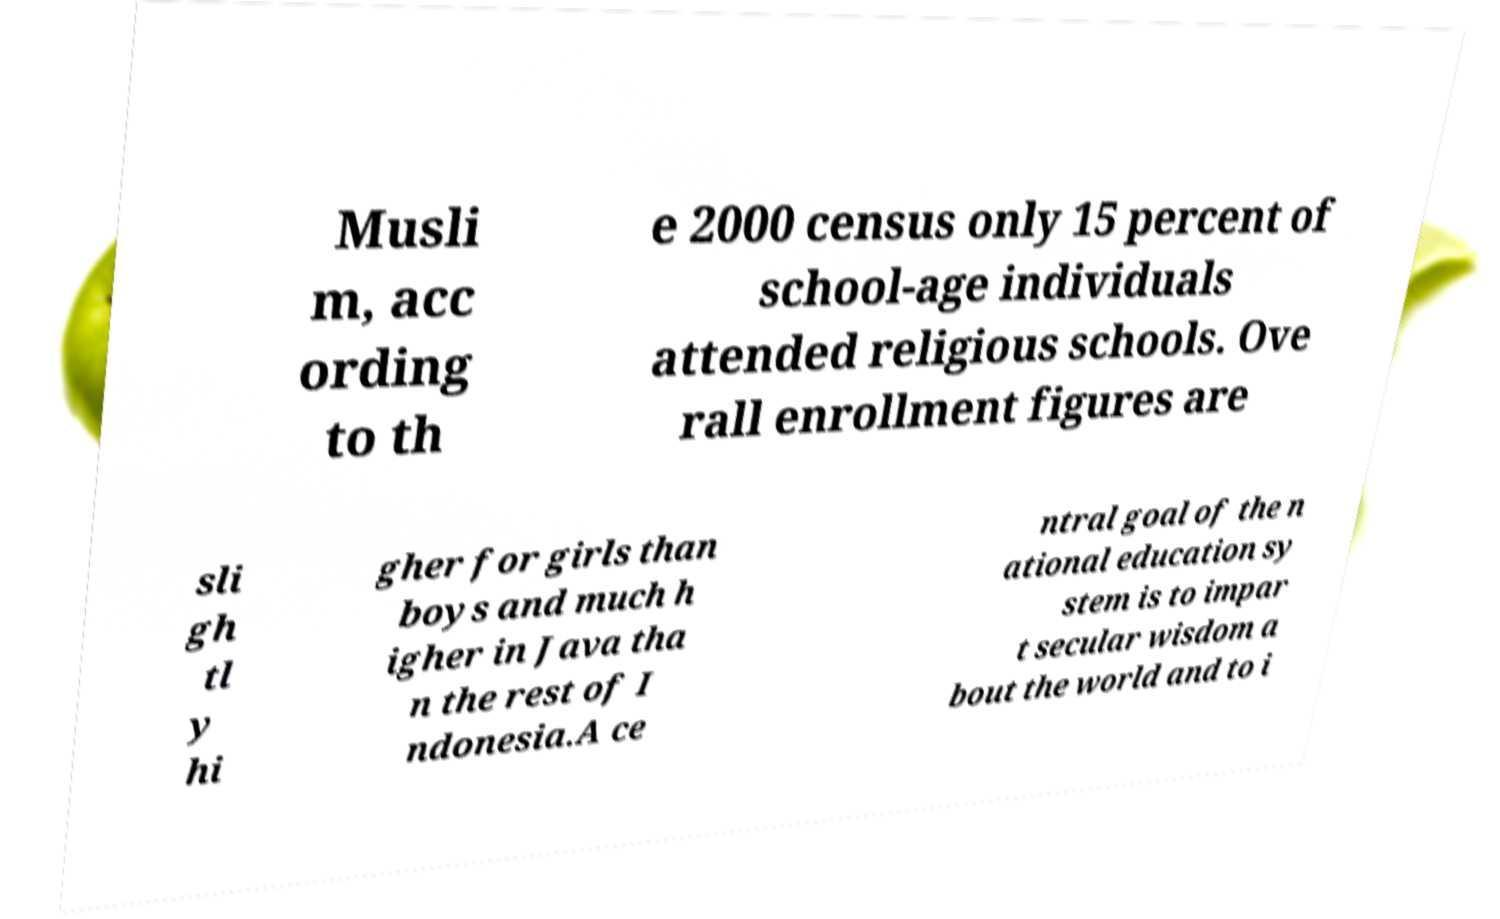Could you assist in decoding the text presented in this image and type it out clearly? Musli m, acc ording to th e 2000 census only 15 percent of school-age individuals attended religious schools. Ove rall enrollment figures are sli gh tl y hi gher for girls than boys and much h igher in Java tha n the rest of I ndonesia.A ce ntral goal of the n ational education sy stem is to impar t secular wisdom a bout the world and to i 